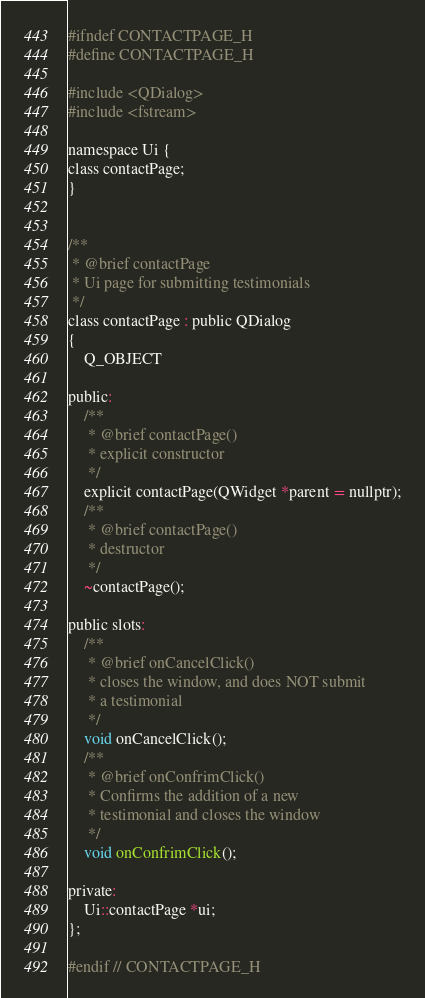<code> <loc_0><loc_0><loc_500><loc_500><_C_>#ifndef CONTACTPAGE_H
#define CONTACTPAGE_H

#include <QDialog>
#include <fstream>

namespace Ui {
class contactPage;
}


/**
 * @brief contactPage
 * Ui page for submitting testimonials
 */
class contactPage : public QDialog
{
    Q_OBJECT

public:
    /**
     * @brief contactPage()
     * explicit constructor
     */
    explicit contactPage(QWidget *parent = nullptr);
    /**
     * @brief contactPage()
     * destructor
     */
    ~contactPage();

public slots:
    /**
     * @brief onCancelClick()
     * closes the window, and does NOT submit
     * a testimonial
     */
    void onCancelClick();
    /**
     * @brief onConfrimClick()
     * Confirms the addition of a new
     * testimonial and closes the window
     */
    void onConfrimClick();

private:
    Ui::contactPage *ui;
};

#endif // CONTACTPAGE_H
</code> 